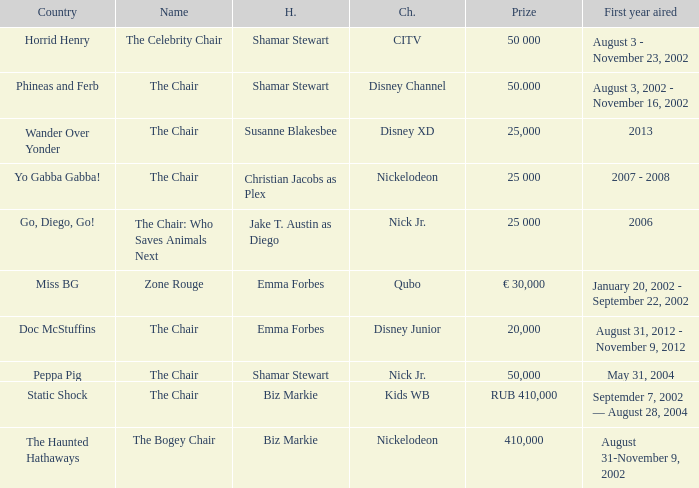What was the host of Horrid Henry? Shamar Stewart. 